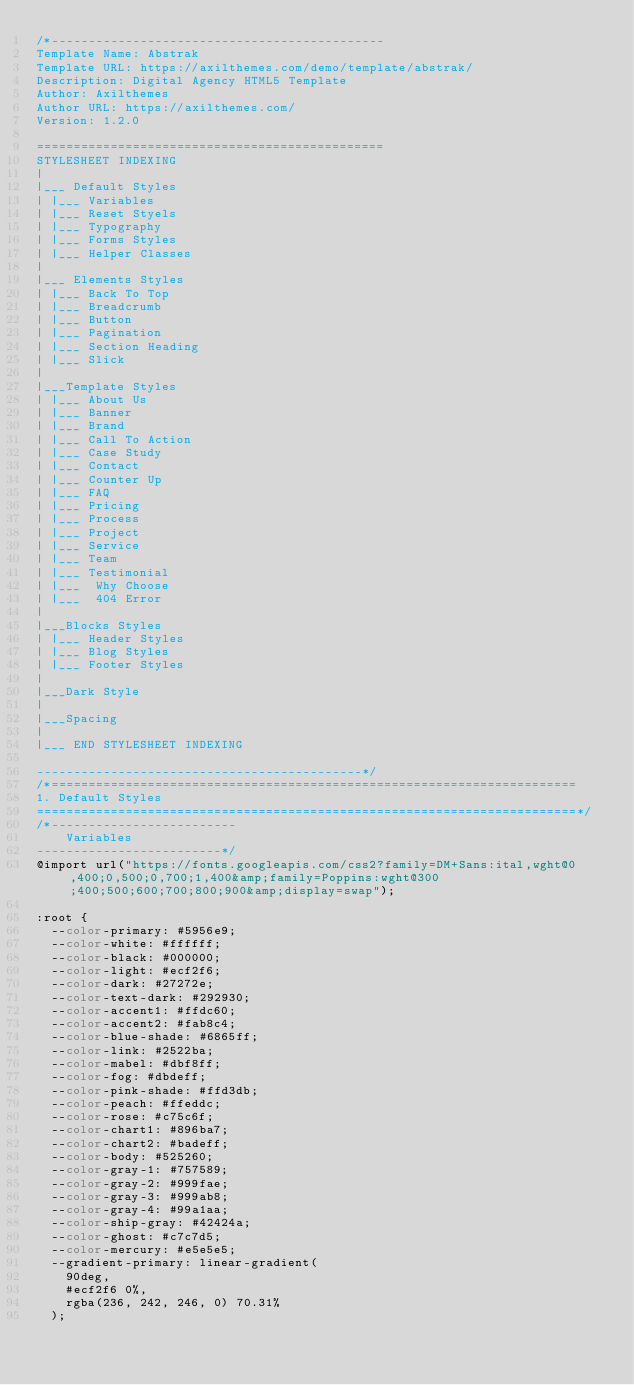Convert code to text. <code><loc_0><loc_0><loc_500><loc_500><_CSS_>/*---------------------------------------------
Template Name: Abstrak
Template URL: https://axilthemes.com/demo/template/abstrak/
Description: Digital Agency HTML5 Template
Author: Axilthemes
Author URL: https://axilthemes.com/
Version: 1.2.0

===============================================   
STYLESHEET INDEXING
|
|___ Default Styles
|	|___ Variables
|	|___ Reset Styels
|	|___ Typography
|	|___ Forms Styles 
|	|___ Helper Classes 
|
|___ Elements Styles
|	|___ Back To Top
|	|___ Breadcrumb
|	|___ Button
|	|___ Pagination 
|	|___ Section Heading
|	|___ Slick 
|
|___Template Styles
|	|___ About Us
|	|___ Banner
|	|___ Brand
|	|___ Call To Action
|	|___ Case Study
|	|___ Contact
|	|___ Counter Up
|	|___ FAQ
|	|___ Pricing
|	|___ Process
|	|___ Project
|	|___ Service
|	|___ Team
|	|___ Testimonial
|	|___  Why Choose
|	|___  404 Error
|
|___Blocks Styles
|	|___ Header Styles
|	|___ Blog Styles
|	|___ Footer Styles
|
|___Dark Style
|
|___Spacing
|
|___ END STYLESHEET INDEXING

--------------------------------------------*/
/*=======================================================================
1. Default Styles
=========================================================================*/
/*-------------------------
    Variables
-------------------------*/
@import url("https://fonts.googleapis.com/css2?family=DM+Sans:ital,wght@0,400;0,500;0,700;1,400&amp;family=Poppins:wght@300;400;500;600;700;800;900&amp;display=swap");

:root {
	--color-primary: #5956e9;
	--color-white: #ffffff;
	--color-black: #000000;
	--color-light: #ecf2f6;
	--color-dark: #27272e;
	--color-text-dark: #292930;
	--color-accent1: #ffdc60;
	--color-accent2: #fab8c4;
	--color-blue-shade: #6865ff;
	--color-link: #2522ba;
	--color-mabel: #dbf8ff;
	--color-fog: #dbdeff;
	--color-pink-shade: #ffd3db;
	--color-peach: #ffeddc;
	--color-rose: #c75c6f;
	--color-chart1: #896ba7;
	--color-chart2: #badeff;
	--color-body: #525260;
	--color-gray-1: #757589;
	--color-gray-2: #999fae;
	--color-gray-3: #999ab8;
	--color-gray-4: #99a1aa;
	--color-ship-gray: #42424a;
	--color-ghost: #c7c7d5;
	--color-mercury: #e5e5e5;
	--gradient-primary: linear-gradient(
		90deg,
		#ecf2f6 0%,
		rgba(236, 242, 246, 0) 70.31%
	);</code> 